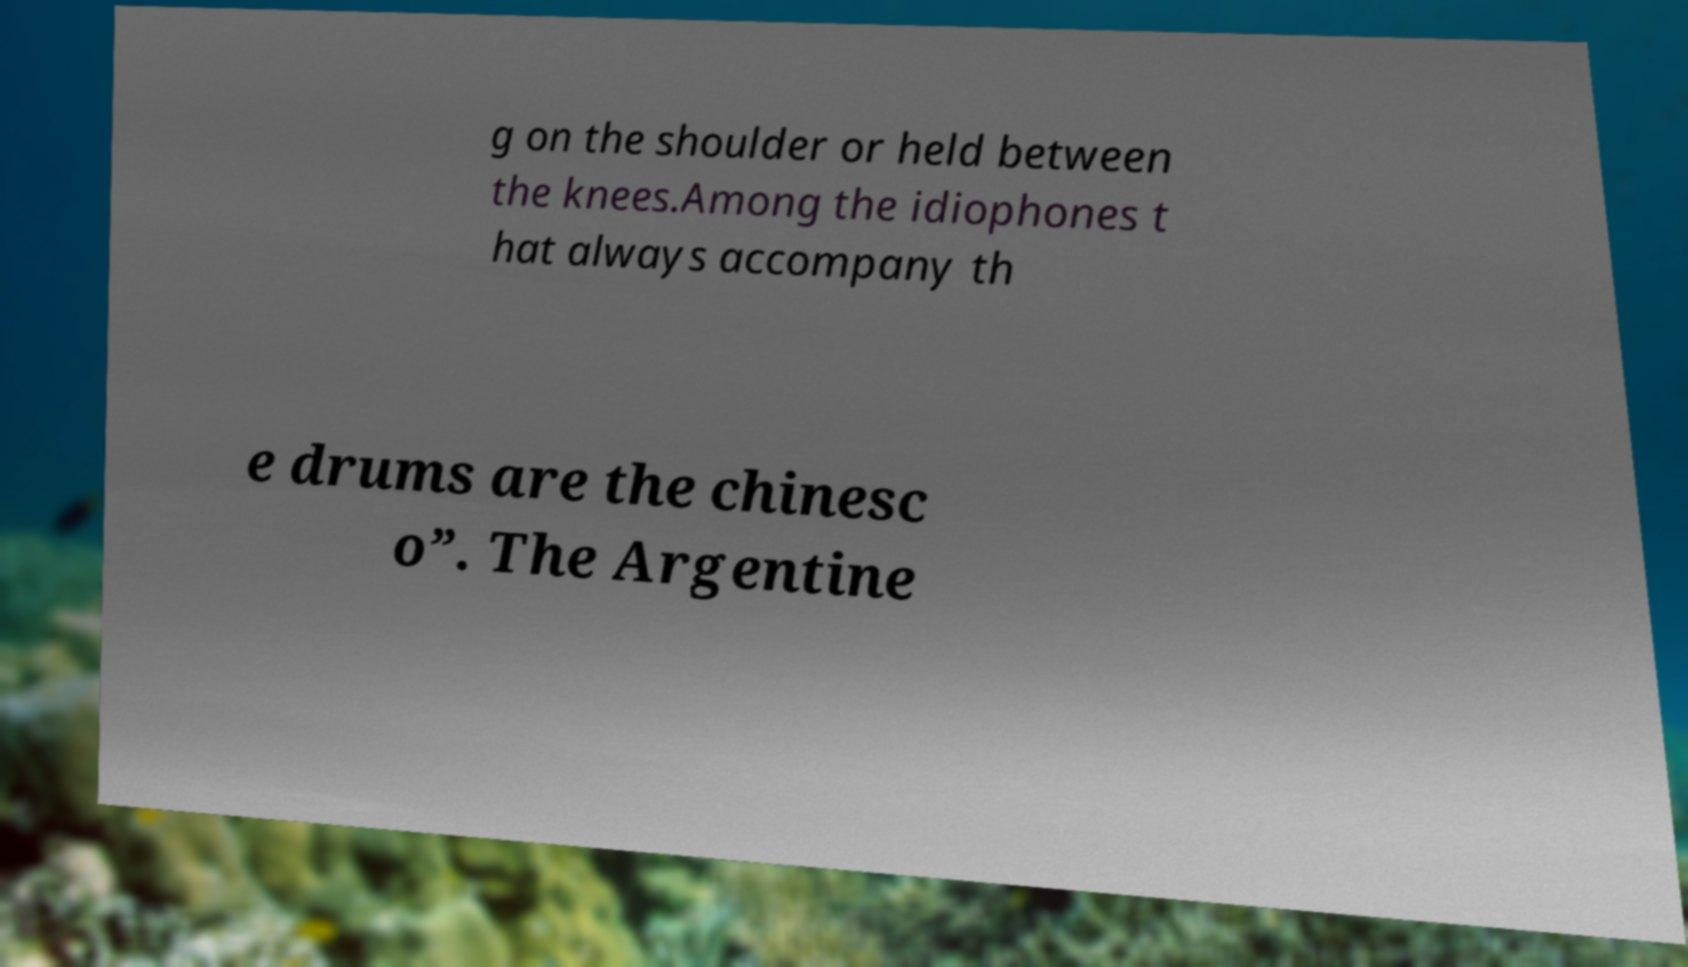I need the written content from this picture converted into text. Can you do that? g on the shoulder or held between the knees.Among the idiophones t hat always accompany th e drums are the chinesc o”. The Argentine 